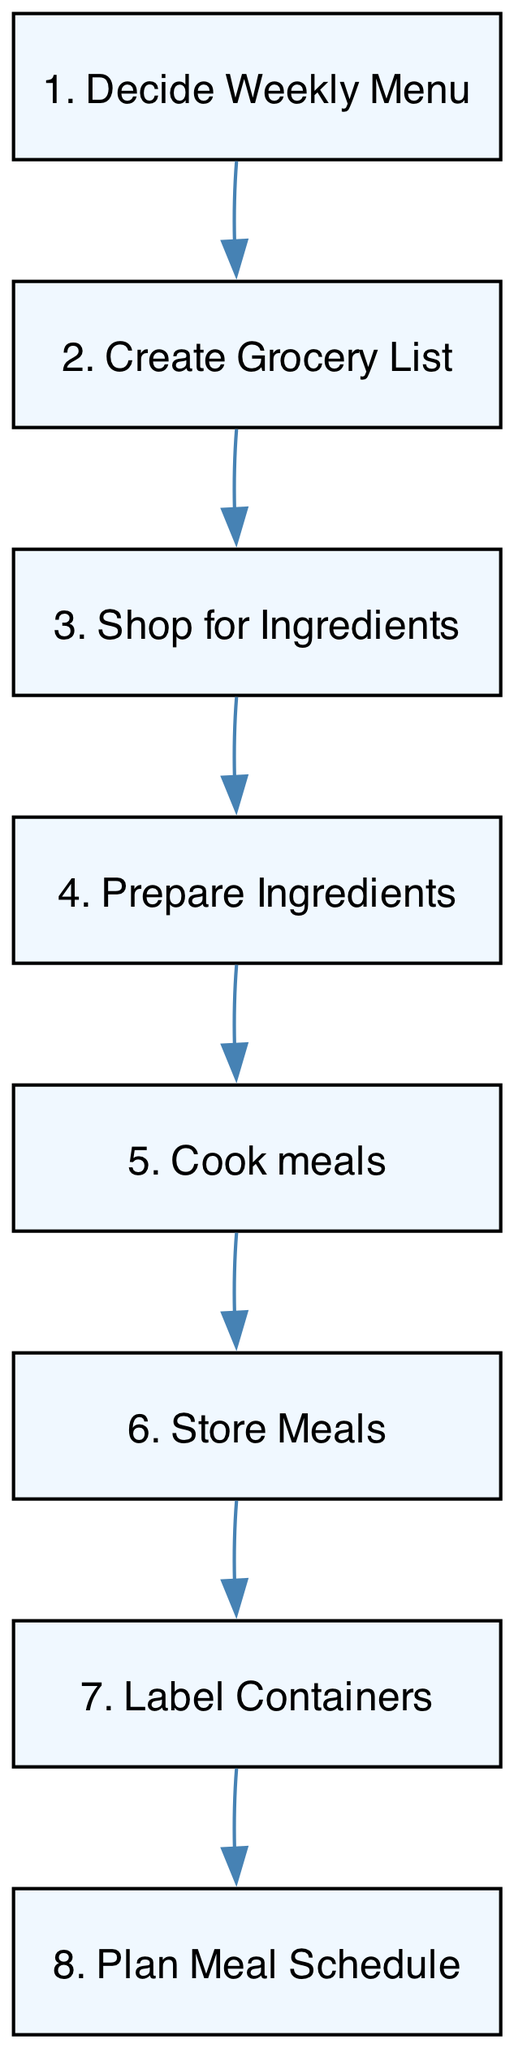What is the first step in the meal preparation process? The first step listed in the diagram is "Decide Weekly Menu," which indicates that selecting meals based on nutritional needs is the starting point for the process.
Answer: Decide Weekly Menu How many steps are in the diagram? The diagram consists of eight distinct steps, each representing a different part of the weekly meal preparation process, from deciding the menu to labeling containers.
Answer: Eight Which step comes after "Prepare Ingredients"? Following "Prepare Ingredients," the next step is "Cook meals," indicating that the preparation of ingredients is completed before cooking begins.
Answer: Cook meals What is the last step in the meal preparation process? The final step in the process is "Plan Meal Schedule," which suggests that after all meals are prepared and stored, it's important to create a schedule for when to eat them.
Answer: Plan Meal Schedule How are the steps in the diagram connected? The steps are connected sequentially, with each step leading to the next, which illustrates the progression of tasks in the weekly meal preparation process.
Answer: Sequentially Which step does not have any incoming edges? The step "Decide Weekly Menu" does not have any incoming edges as it is the very first step to commence the meal preparation process.
Answer: Decide Weekly Menu How does one transition from shopping to preparation? The transition from "Shop for Ingredients" to "Prepare Ingredients" occurs after completing the shopping phase, indicating that after purchasing the items, one moves directly to the preparation of those items.
Answer: Prepare Ingredients What action is associated with "Label Containers"? The action associated with "Label Containers" is to clearly indicate names and dates on the meal containers to ensure proper identification and storage.
Answer: Label containers 